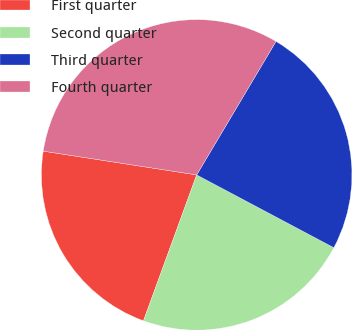Convert chart to OTSL. <chart><loc_0><loc_0><loc_500><loc_500><pie_chart><fcel>First quarter<fcel>Second quarter<fcel>Third quarter<fcel>Fourth quarter<nl><fcel>21.88%<fcel>22.8%<fcel>24.23%<fcel>31.09%<nl></chart> 